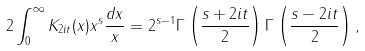<formula> <loc_0><loc_0><loc_500><loc_500>2 \int _ { 0 } ^ { \infty } K _ { 2 i t } ( x ) x ^ { s } \frac { d x } { x } = 2 ^ { s - 1 } \Gamma \left ( \frac { s + 2 i t } { 2 } \right ) \Gamma \left ( \frac { s - 2 i t } { 2 } \right ) ,</formula> 